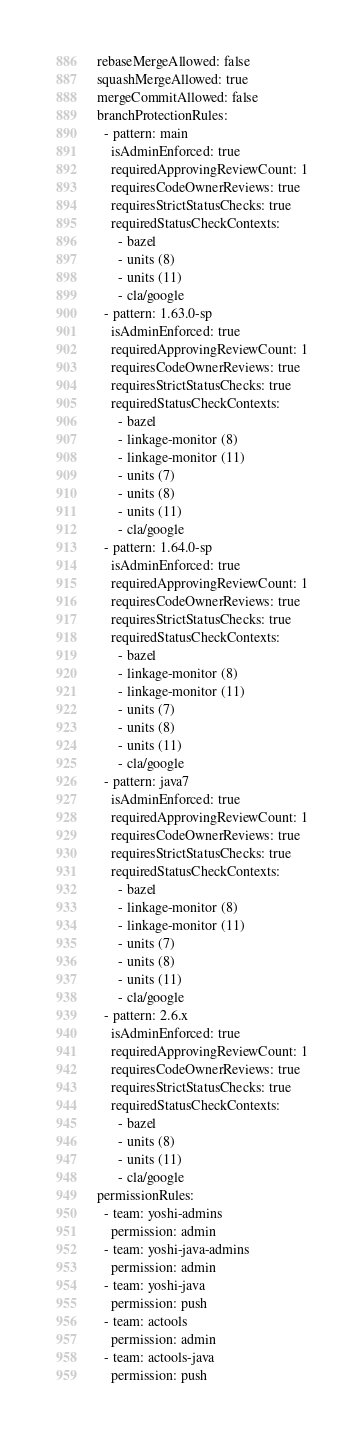Convert code to text. <code><loc_0><loc_0><loc_500><loc_500><_YAML_>rebaseMergeAllowed: false
squashMergeAllowed: true
mergeCommitAllowed: false
branchProtectionRules:
  - pattern: main
    isAdminEnforced: true
    requiredApprovingReviewCount: 1
    requiresCodeOwnerReviews: true
    requiresStrictStatusChecks: true
    requiredStatusCheckContexts:
      - bazel
      - units (8)
      - units (11)
      - cla/google
  - pattern: 1.63.0-sp
    isAdminEnforced: true
    requiredApprovingReviewCount: 1
    requiresCodeOwnerReviews: true
    requiresStrictStatusChecks: true
    requiredStatusCheckContexts:
      - bazel
      - linkage-monitor (8)
      - linkage-monitor (11)
      - units (7)
      - units (8)
      - units (11)
      - cla/google
  - pattern: 1.64.0-sp
    isAdminEnforced: true
    requiredApprovingReviewCount: 1
    requiresCodeOwnerReviews: true
    requiresStrictStatusChecks: true
    requiredStatusCheckContexts:
      - bazel
      - linkage-monitor (8)
      - linkage-monitor (11)
      - units (7)
      - units (8)
      - units (11)
      - cla/google
  - pattern: java7
    isAdminEnforced: true
    requiredApprovingReviewCount: 1
    requiresCodeOwnerReviews: true
    requiresStrictStatusChecks: true
    requiredStatusCheckContexts:
      - bazel
      - linkage-monitor (8)
      - linkage-monitor (11)
      - units (7)
      - units (8)
      - units (11)
      - cla/google
  - pattern: 2.6.x
    isAdminEnforced: true
    requiredApprovingReviewCount: 1
    requiresCodeOwnerReviews: true
    requiresStrictStatusChecks: true
    requiredStatusCheckContexts:
      - bazel
      - units (8)
      - units (11)
      - cla/google
permissionRules:
  - team: yoshi-admins
    permission: admin
  - team: yoshi-java-admins
    permission: admin
  - team: yoshi-java
    permission: push
  - team: actools
    permission: admin
  - team: actools-java
    permission: push
</code> 